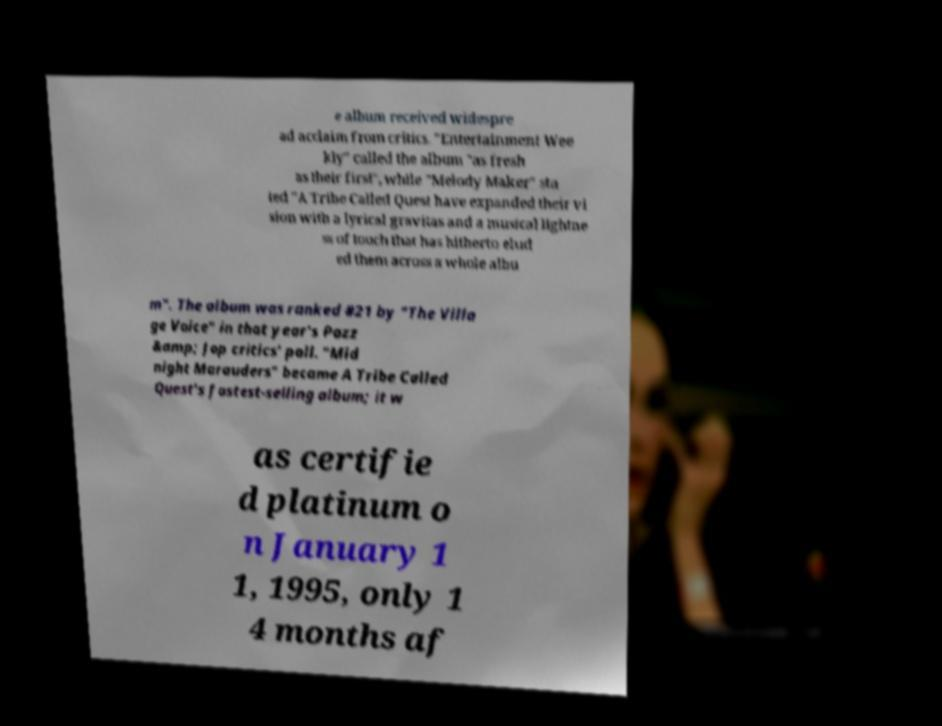Can you accurately transcribe the text from the provided image for me? e album received widespre ad acclaim from critics. "Entertainment Wee kly" called the album "as fresh as their first", while "Melody Maker" sta ted "A Tribe Called Quest have expanded their vi sion with a lyrical gravitas and a musical lightne ss of touch that has hitherto elud ed them across a whole albu m". The album was ranked #21 by "The Villa ge Voice" in that year's Pazz &amp; Jop critics' poll. "Mid night Marauders" became A Tribe Called Quest's fastest-selling album; it w as certifie d platinum o n January 1 1, 1995, only 1 4 months af 